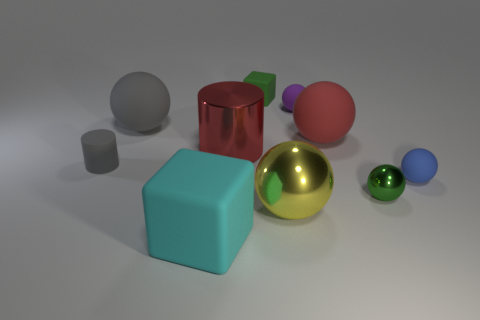Subtract all red matte balls. How many balls are left? 5 Subtract 3 balls. How many balls are left? 3 Subtract all purple spheres. How many spheres are left? 5 Subtract all blocks. How many objects are left? 8 Subtract all big brown cylinders. Subtract all yellow metallic balls. How many objects are left? 9 Add 3 gray rubber things. How many gray rubber things are left? 5 Add 6 tiny red metal cylinders. How many tiny red metal cylinders exist? 6 Subtract 1 yellow balls. How many objects are left? 9 Subtract all red cylinders. Subtract all purple spheres. How many cylinders are left? 1 